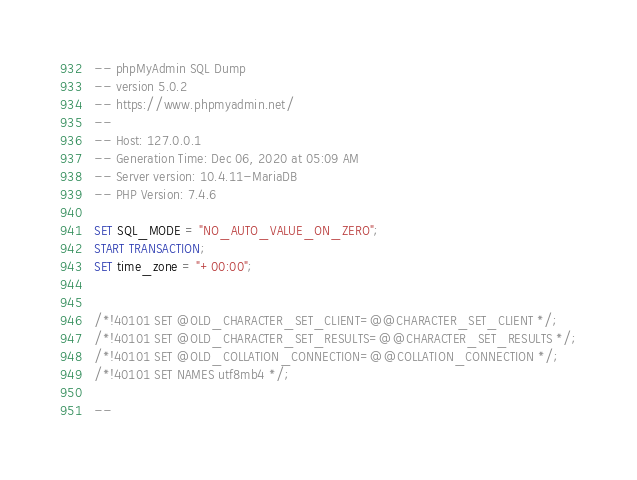Convert code to text. <code><loc_0><loc_0><loc_500><loc_500><_SQL_>-- phpMyAdmin SQL Dump
-- version 5.0.2
-- https://www.phpmyadmin.net/
--
-- Host: 127.0.0.1
-- Generation Time: Dec 06, 2020 at 05:09 AM
-- Server version: 10.4.11-MariaDB
-- PHP Version: 7.4.6

SET SQL_MODE = "NO_AUTO_VALUE_ON_ZERO";
START TRANSACTION;
SET time_zone = "+00:00";


/*!40101 SET @OLD_CHARACTER_SET_CLIENT=@@CHARACTER_SET_CLIENT */;
/*!40101 SET @OLD_CHARACTER_SET_RESULTS=@@CHARACTER_SET_RESULTS */;
/*!40101 SET @OLD_COLLATION_CONNECTION=@@COLLATION_CONNECTION */;
/*!40101 SET NAMES utf8mb4 */;

--</code> 